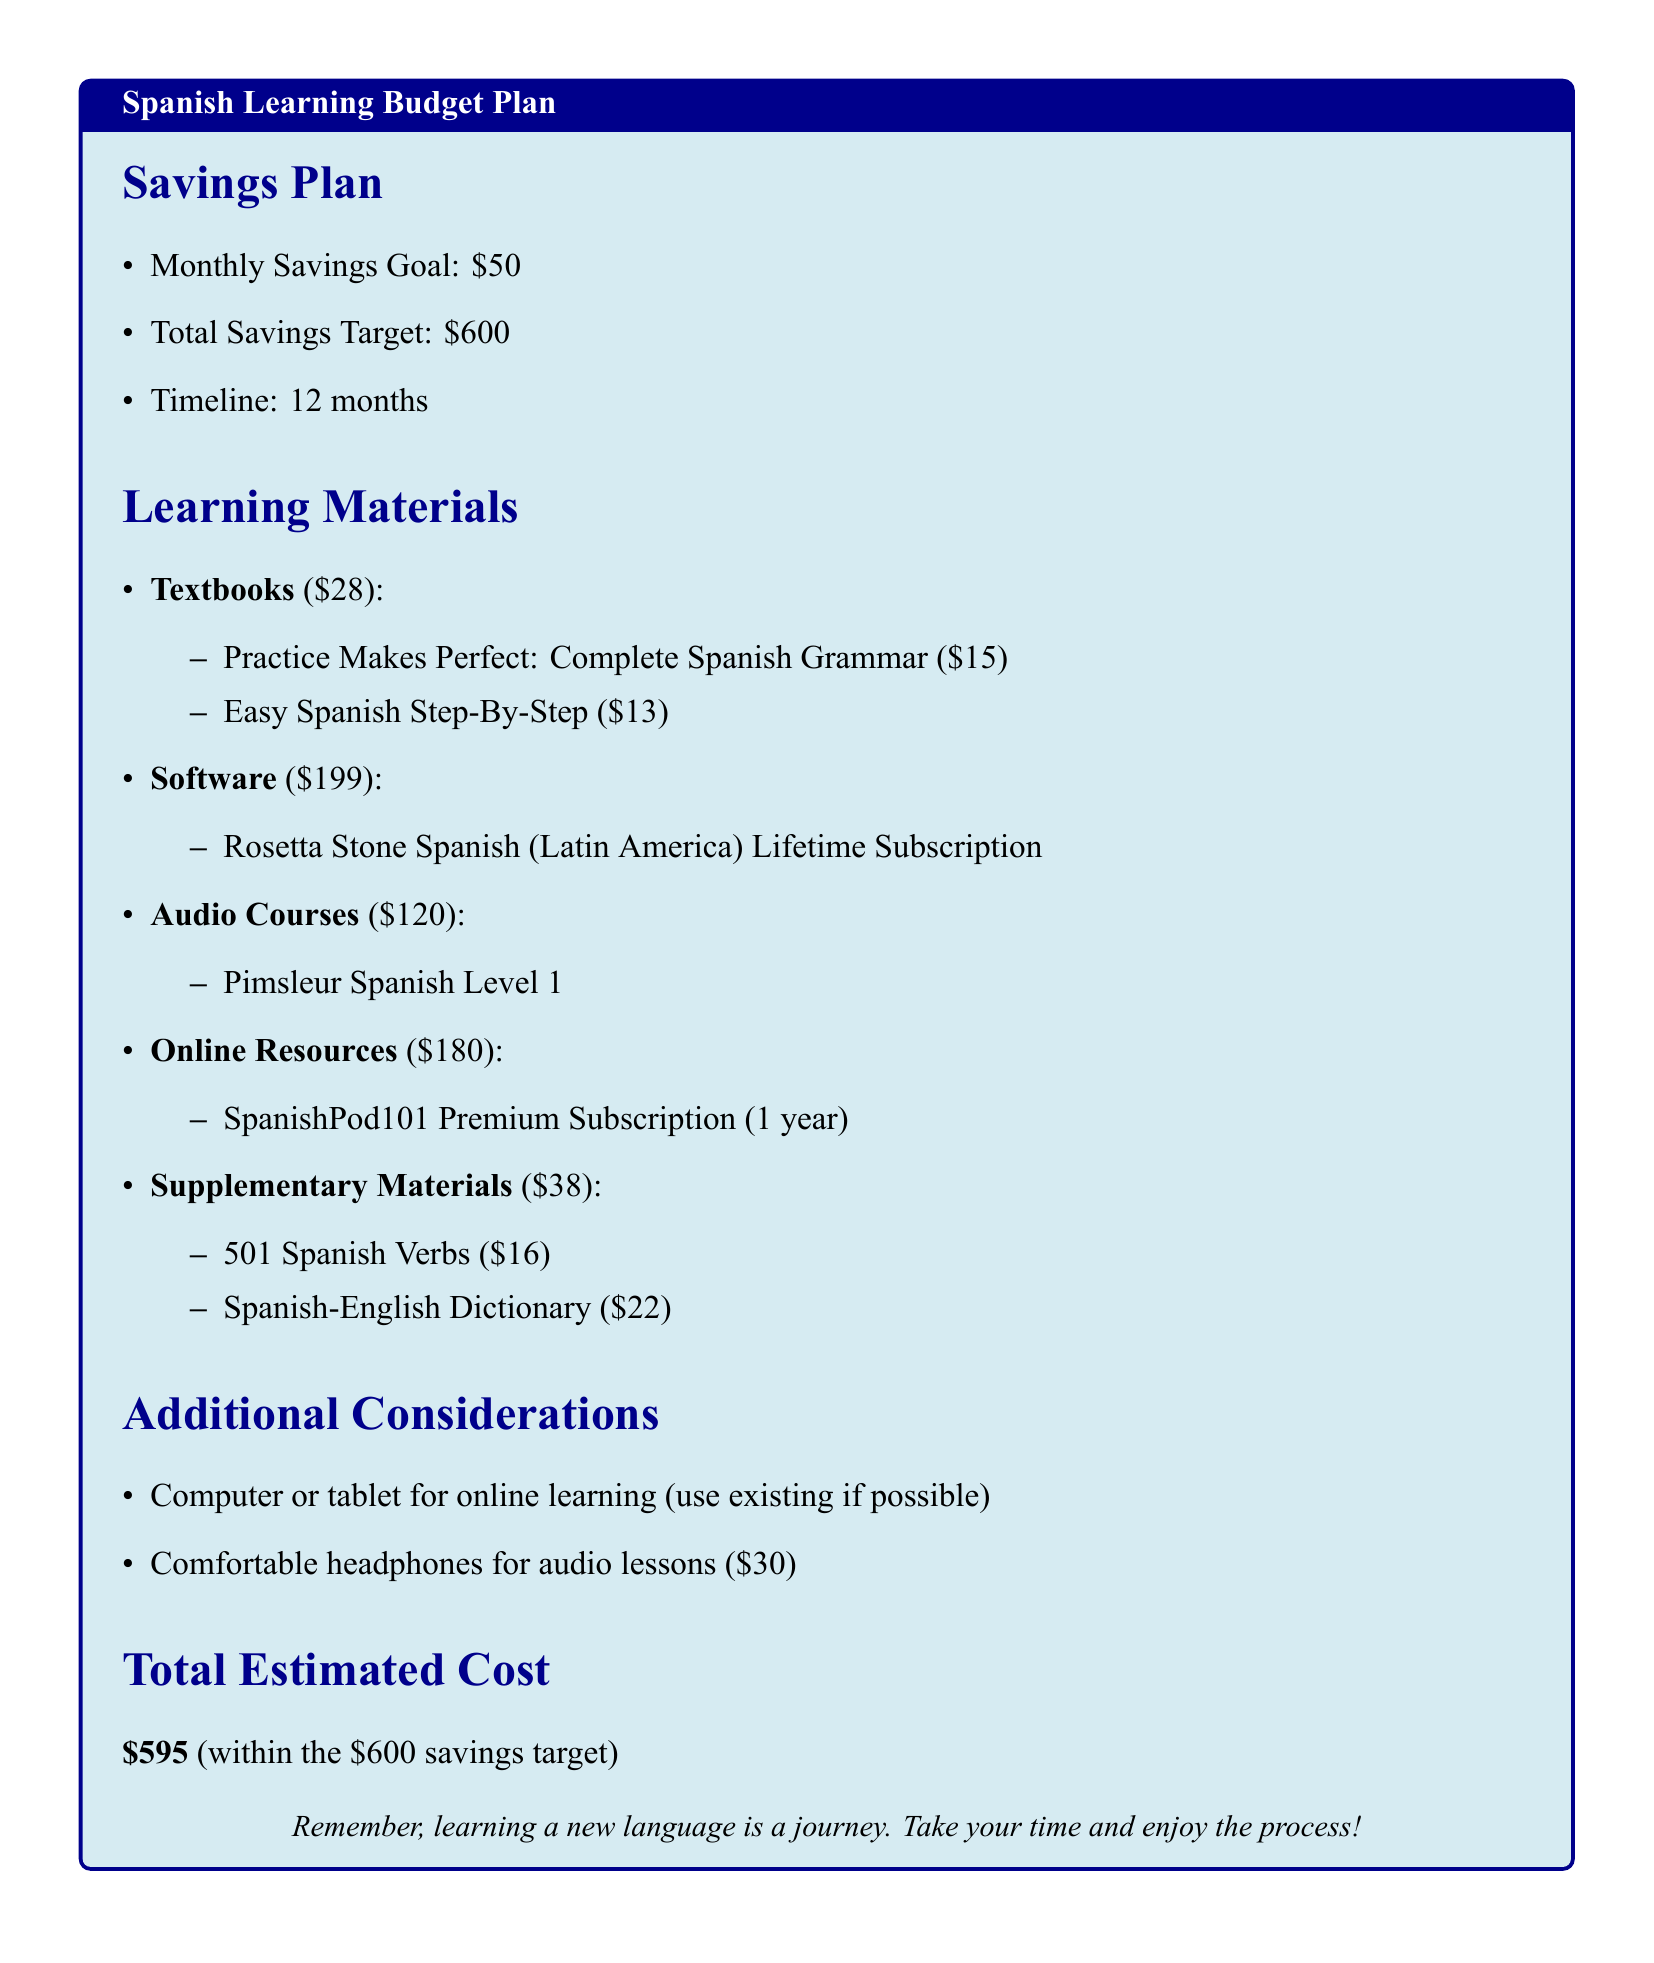What is the monthly savings goal? The monthly savings goal is explicitly listed in the Savings Plan section.
Answer: $50 How much is the Rosetta Stone subscription? The cost of the Rosetta Stone subscription is detailed under Software in the Learning Materials section.
Answer: $199 What is the total estimated cost? The total estimated cost is provided at the end of the Learning Materials section.
Answer: $595 How many months is the savings timeline? The timeline for the savings goal is indicated in the Savings Plan section.
Answer: 12 months What is the cost of the Spanish-English Dictionary? The cost of the Spanish-English Dictionary is provided in the Supplementary Materials list.
Answer: $22 What is the total amount allocated for online resources? The amount for online resources is mentioned in the Learning Materials section and needs to be retrieved directly from it.
Answer: $180 What is the title of the textbook that costs $15? The title of the textbook priced at $15 is listed under Textbooks in the Learning Materials section.
Answer: Practice Makes Perfect: Complete Spanish Grammar How much are comfortable headphones for audio lessons? The cost for comfortable headphones is specified in the Additional Considerations section.
Answer: $30 What is the total savings target? The total savings target is stated in the Savings Plan section.
Answer: $600 How many audio courses are listed in the budget? The number of audio courses can be counted in the Learning Materials section, where they are listed.
Answer: 1 